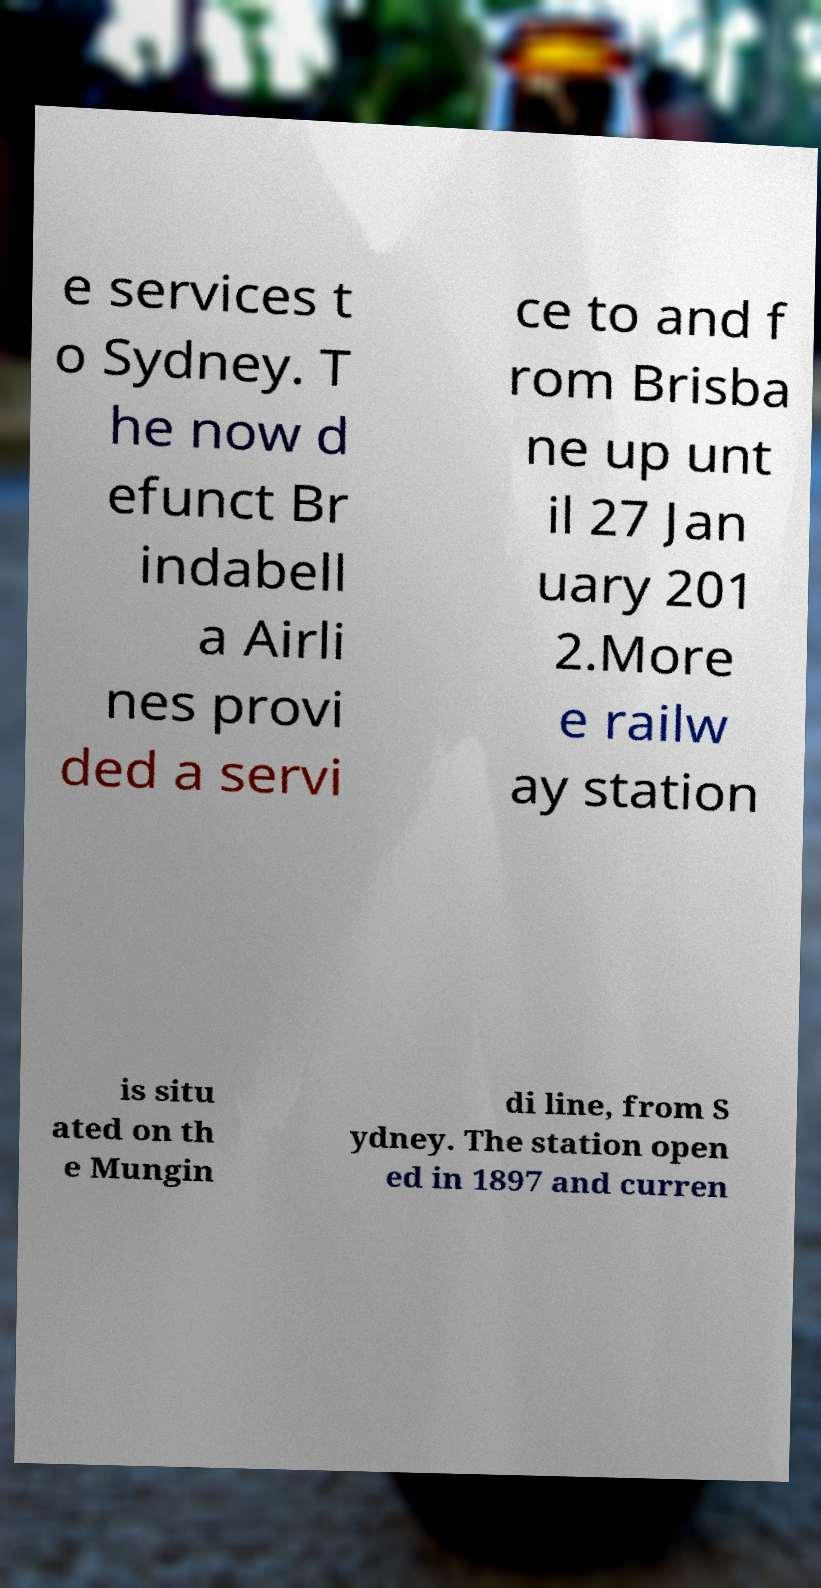Can you accurately transcribe the text from the provided image for me? e services t o Sydney. T he now d efunct Br indabell a Airli nes provi ded a servi ce to and f rom Brisba ne up unt il 27 Jan uary 201 2.More e railw ay station is situ ated on th e Mungin di line, from S ydney. The station open ed in 1897 and curren 